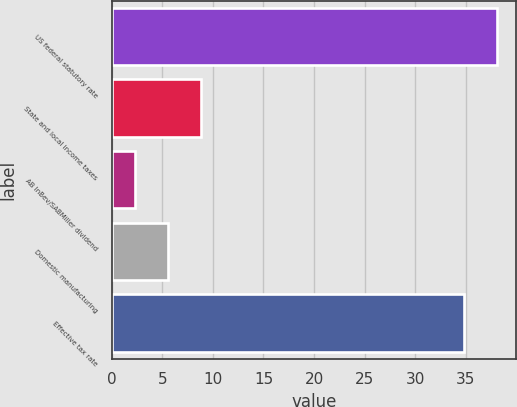<chart> <loc_0><loc_0><loc_500><loc_500><bar_chart><fcel>US federal statutory rate<fcel>State and local income taxes<fcel>AB InBev/SABMiller dividend<fcel>Domestic manufacturing<fcel>Effective tax rate<nl><fcel>38.07<fcel>8.84<fcel>2.3<fcel>5.57<fcel>34.8<nl></chart> 